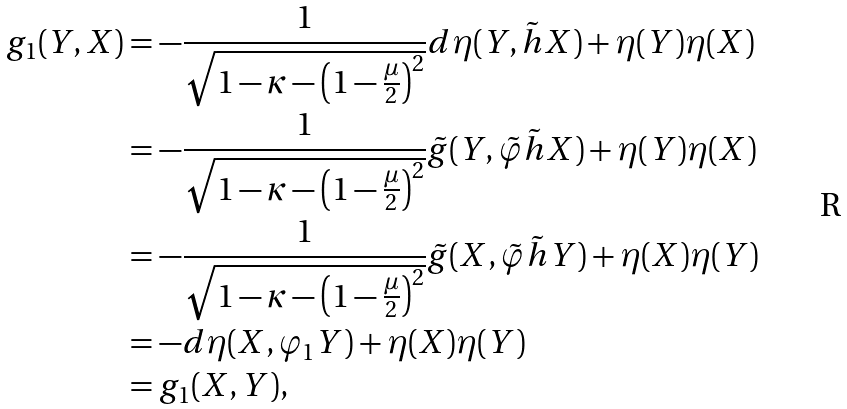<formula> <loc_0><loc_0><loc_500><loc_500>g _ { 1 } ( Y , X ) & = - \frac { 1 } { \sqrt { 1 - \kappa - \left ( 1 - \frac { \mu } { 2 } \right ) ^ { 2 } } } d \eta ( Y , \tilde { h } X ) + \eta ( Y ) \eta ( X ) \\ & = - \frac { 1 } { \sqrt { 1 - \kappa - \left ( 1 - \frac { \mu } { 2 } \right ) ^ { 2 } } } \tilde { g } ( Y , \tilde { \varphi } \tilde { h } X ) + \eta ( Y ) \eta ( X ) \\ & = - \frac { 1 } { \sqrt { 1 - \kappa - \left ( 1 - \frac { \mu } { 2 } \right ) ^ { 2 } } } \tilde { g } ( X , \tilde { \varphi } \tilde { h } Y ) + \eta ( X ) \eta ( Y ) \\ & = - d \eta ( X , \varphi _ { 1 } Y ) + \eta ( X ) \eta ( Y ) \\ & = g _ { 1 } ( X , Y ) ,</formula> 